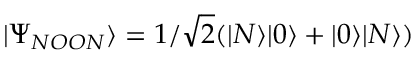<formula> <loc_0><loc_0><loc_500><loc_500>| \Psi _ { N O O N } \rangle = 1 / \sqrt { 2 } ( | N \rangle | 0 \rangle + | 0 \rangle | N \rangle )</formula> 